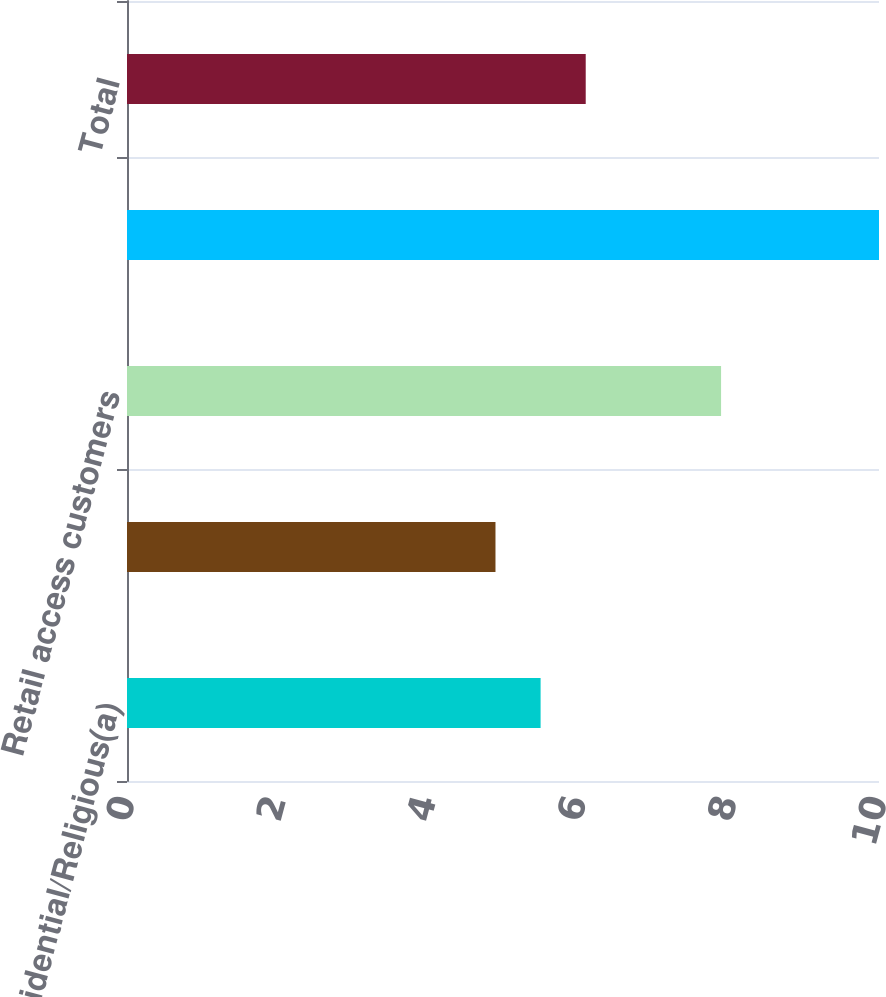Convert chart. <chart><loc_0><loc_0><loc_500><loc_500><bar_chart><fcel>Residential/Religious(a)<fcel>Commercial/Industrial<fcel>Retail access customers<fcel>Public authorities<fcel>Total<nl><fcel>5.5<fcel>4.9<fcel>7.9<fcel>10<fcel>6.1<nl></chart> 